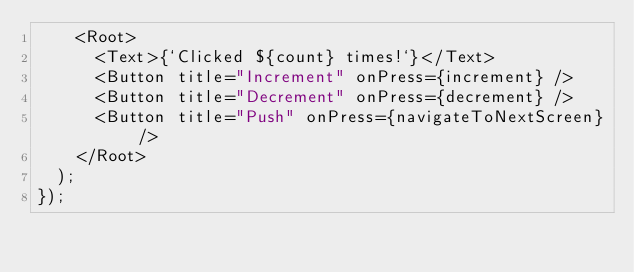<code> <loc_0><loc_0><loc_500><loc_500><_TypeScript_>    <Root>
      <Text>{`Clicked ${count} times!`}</Text>
      <Button title="Increment" onPress={increment} />
      <Button title="Decrement" onPress={decrement} />
      <Button title="Push" onPress={navigateToNextScreen} />
    </Root>
  );
});
</code> 